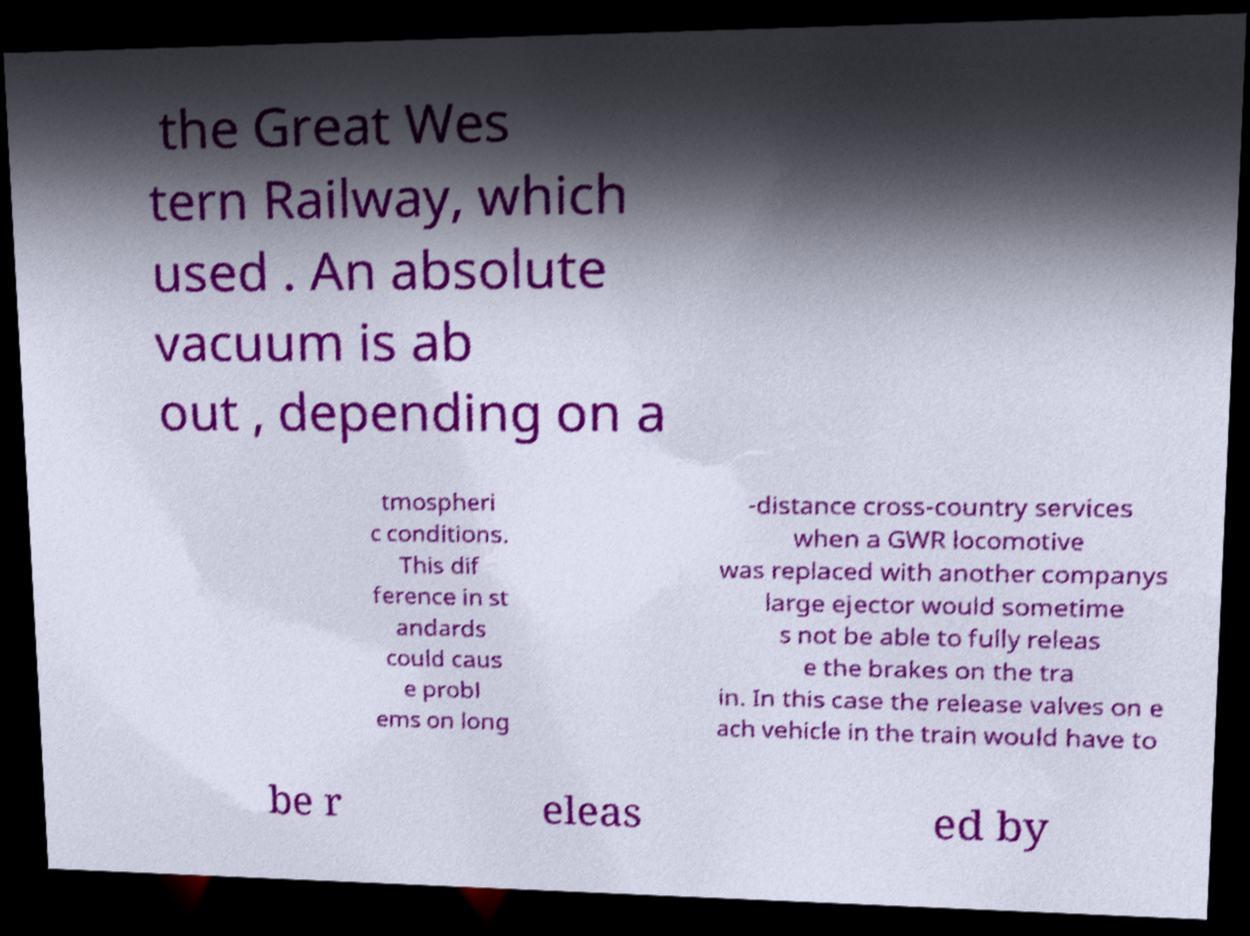Could you assist in decoding the text presented in this image and type it out clearly? the Great Wes tern Railway, which used . An absolute vacuum is ab out , depending on a tmospheri c conditions. This dif ference in st andards could caus e probl ems on long -distance cross-country services when a GWR locomotive was replaced with another companys large ejector would sometime s not be able to fully releas e the brakes on the tra in. In this case the release valves on e ach vehicle in the train would have to be r eleas ed by 